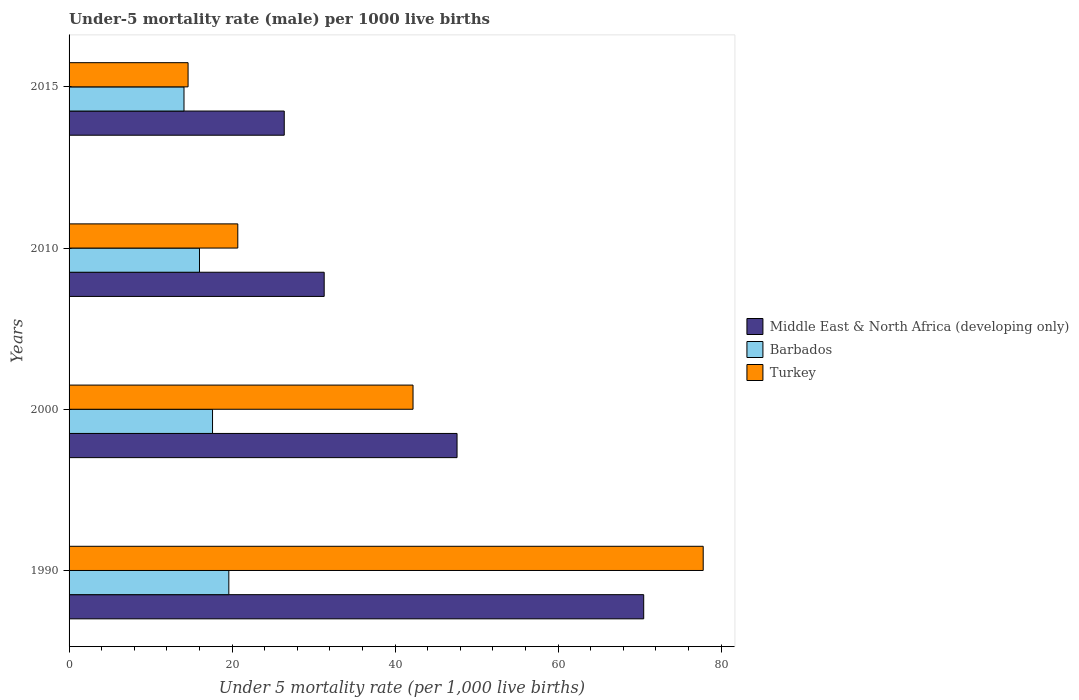How many different coloured bars are there?
Your answer should be very brief. 3. What is the label of the 1st group of bars from the top?
Keep it short and to the point. 2015. In how many cases, is the number of bars for a given year not equal to the number of legend labels?
Offer a very short reply. 0. What is the under-five mortality rate in Turkey in 2015?
Give a very brief answer. 14.6. Across all years, what is the maximum under-five mortality rate in Turkey?
Your answer should be compact. 77.8. In which year was the under-five mortality rate in Turkey maximum?
Provide a short and direct response. 1990. In which year was the under-five mortality rate in Barbados minimum?
Your response must be concise. 2015. What is the total under-five mortality rate in Middle East & North Africa (developing only) in the graph?
Give a very brief answer. 175.8. What is the difference between the under-five mortality rate in Barbados in 1990 and that in 2015?
Make the answer very short. 5.5. What is the difference between the under-five mortality rate in Middle East & North Africa (developing only) in 1990 and the under-five mortality rate in Turkey in 2000?
Your answer should be compact. 28.3. What is the average under-five mortality rate in Middle East & North Africa (developing only) per year?
Keep it short and to the point. 43.95. In the year 2010, what is the difference between the under-five mortality rate in Turkey and under-five mortality rate in Middle East & North Africa (developing only)?
Your response must be concise. -10.6. What is the ratio of the under-five mortality rate in Turkey in 1990 to that in 2010?
Your answer should be compact. 3.76. What is the difference between the highest and the second highest under-five mortality rate in Turkey?
Provide a succinct answer. 35.6. What is the difference between the highest and the lowest under-five mortality rate in Middle East & North Africa (developing only)?
Your answer should be compact. 44.1. Is the sum of the under-five mortality rate in Turkey in 2000 and 2010 greater than the maximum under-five mortality rate in Middle East & North Africa (developing only) across all years?
Provide a short and direct response. No. What does the 2nd bar from the top in 2010 represents?
Offer a terse response. Barbados. What does the 2nd bar from the bottom in 2015 represents?
Provide a succinct answer. Barbados. How many bars are there?
Keep it short and to the point. 12. Are all the bars in the graph horizontal?
Ensure brevity in your answer.  Yes. Are the values on the major ticks of X-axis written in scientific E-notation?
Provide a short and direct response. No. Does the graph contain grids?
Your answer should be compact. No. Where does the legend appear in the graph?
Your answer should be very brief. Center right. How many legend labels are there?
Your answer should be compact. 3. How are the legend labels stacked?
Your answer should be very brief. Vertical. What is the title of the graph?
Make the answer very short. Under-5 mortality rate (male) per 1000 live births. What is the label or title of the X-axis?
Make the answer very short. Under 5 mortality rate (per 1,0 live births). What is the label or title of the Y-axis?
Make the answer very short. Years. What is the Under 5 mortality rate (per 1,000 live births) in Middle East & North Africa (developing only) in 1990?
Give a very brief answer. 70.5. What is the Under 5 mortality rate (per 1,000 live births) in Barbados in 1990?
Provide a short and direct response. 19.6. What is the Under 5 mortality rate (per 1,000 live births) in Turkey in 1990?
Your answer should be compact. 77.8. What is the Under 5 mortality rate (per 1,000 live births) of Middle East & North Africa (developing only) in 2000?
Offer a terse response. 47.6. What is the Under 5 mortality rate (per 1,000 live births) in Barbados in 2000?
Your answer should be compact. 17.6. What is the Under 5 mortality rate (per 1,000 live births) in Turkey in 2000?
Offer a terse response. 42.2. What is the Under 5 mortality rate (per 1,000 live births) of Middle East & North Africa (developing only) in 2010?
Your answer should be very brief. 31.3. What is the Under 5 mortality rate (per 1,000 live births) in Barbados in 2010?
Give a very brief answer. 16. What is the Under 5 mortality rate (per 1,000 live births) of Turkey in 2010?
Offer a very short reply. 20.7. What is the Under 5 mortality rate (per 1,000 live births) of Middle East & North Africa (developing only) in 2015?
Make the answer very short. 26.4. Across all years, what is the maximum Under 5 mortality rate (per 1,000 live births) in Middle East & North Africa (developing only)?
Your answer should be compact. 70.5. Across all years, what is the maximum Under 5 mortality rate (per 1,000 live births) of Barbados?
Provide a short and direct response. 19.6. Across all years, what is the maximum Under 5 mortality rate (per 1,000 live births) of Turkey?
Provide a succinct answer. 77.8. Across all years, what is the minimum Under 5 mortality rate (per 1,000 live births) of Middle East & North Africa (developing only)?
Ensure brevity in your answer.  26.4. What is the total Under 5 mortality rate (per 1,000 live births) of Middle East & North Africa (developing only) in the graph?
Keep it short and to the point. 175.8. What is the total Under 5 mortality rate (per 1,000 live births) of Barbados in the graph?
Provide a succinct answer. 67.3. What is the total Under 5 mortality rate (per 1,000 live births) of Turkey in the graph?
Offer a very short reply. 155.3. What is the difference between the Under 5 mortality rate (per 1,000 live births) of Middle East & North Africa (developing only) in 1990 and that in 2000?
Ensure brevity in your answer.  22.9. What is the difference between the Under 5 mortality rate (per 1,000 live births) of Turkey in 1990 and that in 2000?
Offer a terse response. 35.6. What is the difference between the Under 5 mortality rate (per 1,000 live births) in Middle East & North Africa (developing only) in 1990 and that in 2010?
Your response must be concise. 39.2. What is the difference between the Under 5 mortality rate (per 1,000 live births) of Barbados in 1990 and that in 2010?
Give a very brief answer. 3.6. What is the difference between the Under 5 mortality rate (per 1,000 live births) in Turkey in 1990 and that in 2010?
Keep it short and to the point. 57.1. What is the difference between the Under 5 mortality rate (per 1,000 live births) of Middle East & North Africa (developing only) in 1990 and that in 2015?
Your answer should be very brief. 44.1. What is the difference between the Under 5 mortality rate (per 1,000 live births) in Turkey in 1990 and that in 2015?
Your answer should be compact. 63.2. What is the difference between the Under 5 mortality rate (per 1,000 live births) in Barbados in 2000 and that in 2010?
Your answer should be compact. 1.6. What is the difference between the Under 5 mortality rate (per 1,000 live births) of Middle East & North Africa (developing only) in 2000 and that in 2015?
Offer a terse response. 21.2. What is the difference between the Under 5 mortality rate (per 1,000 live births) in Turkey in 2000 and that in 2015?
Offer a very short reply. 27.6. What is the difference between the Under 5 mortality rate (per 1,000 live births) in Middle East & North Africa (developing only) in 2010 and that in 2015?
Offer a terse response. 4.9. What is the difference between the Under 5 mortality rate (per 1,000 live births) of Barbados in 2010 and that in 2015?
Provide a short and direct response. 1.9. What is the difference between the Under 5 mortality rate (per 1,000 live births) of Turkey in 2010 and that in 2015?
Offer a terse response. 6.1. What is the difference between the Under 5 mortality rate (per 1,000 live births) in Middle East & North Africa (developing only) in 1990 and the Under 5 mortality rate (per 1,000 live births) in Barbados in 2000?
Your answer should be compact. 52.9. What is the difference between the Under 5 mortality rate (per 1,000 live births) of Middle East & North Africa (developing only) in 1990 and the Under 5 mortality rate (per 1,000 live births) of Turkey in 2000?
Your answer should be very brief. 28.3. What is the difference between the Under 5 mortality rate (per 1,000 live births) of Barbados in 1990 and the Under 5 mortality rate (per 1,000 live births) of Turkey in 2000?
Offer a terse response. -22.6. What is the difference between the Under 5 mortality rate (per 1,000 live births) of Middle East & North Africa (developing only) in 1990 and the Under 5 mortality rate (per 1,000 live births) of Barbados in 2010?
Your answer should be compact. 54.5. What is the difference between the Under 5 mortality rate (per 1,000 live births) in Middle East & North Africa (developing only) in 1990 and the Under 5 mortality rate (per 1,000 live births) in Turkey in 2010?
Your response must be concise. 49.8. What is the difference between the Under 5 mortality rate (per 1,000 live births) of Barbados in 1990 and the Under 5 mortality rate (per 1,000 live births) of Turkey in 2010?
Your response must be concise. -1.1. What is the difference between the Under 5 mortality rate (per 1,000 live births) in Middle East & North Africa (developing only) in 1990 and the Under 5 mortality rate (per 1,000 live births) in Barbados in 2015?
Your response must be concise. 56.4. What is the difference between the Under 5 mortality rate (per 1,000 live births) of Middle East & North Africa (developing only) in 1990 and the Under 5 mortality rate (per 1,000 live births) of Turkey in 2015?
Provide a succinct answer. 55.9. What is the difference between the Under 5 mortality rate (per 1,000 live births) of Middle East & North Africa (developing only) in 2000 and the Under 5 mortality rate (per 1,000 live births) of Barbados in 2010?
Offer a very short reply. 31.6. What is the difference between the Under 5 mortality rate (per 1,000 live births) of Middle East & North Africa (developing only) in 2000 and the Under 5 mortality rate (per 1,000 live births) of Turkey in 2010?
Offer a terse response. 26.9. What is the difference between the Under 5 mortality rate (per 1,000 live births) in Middle East & North Africa (developing only) in 2000 and the Under 5 mortality rate (per 1,000 live births) in Barbados in 2015?
Make the answer very short. 33.5. What is the difference between the Under 5 mortality rate (per 1,000 live births) in Middle East & North Africa (developing only) in 2000 and the Under 5 mortality rate (per 1,000 live births) in Turkey in 2015?
Your response must be concise. 33. What is the difference between the Under 5 mortality rate (per 1,000 live births) of Middle East & North Africa (developing only) in 2010 and the Under 5 mortality rate (per 1,000 live births) of Barbados in 2015?
Make the answer very short. 17.2. What is the difference between the Under 5 mortality rate (per 1,000 live births) in Middle East & North Africa (developing only) in 2010 and the Under 5 mortality rate (per 1,000 live births) in Turkey in 2015?
Provide a succinct answer. 16.7. What is the difference between the Under 5 mortality rate (per 1,000 live births) of Barbados in 2010 and the Under 5 mortality rate (per 1,000 live births) of Turkey in 2015?
Give a very brief answer. 1.4. What is the average Under 5 mortality rate (per 1,000 live births) of Middle East & North Africa (developing only) per year?
Offer a very short reply. 43.95. What is the average Under 5 mortality rate (per 1,000 live births) in Barbados per year?
Keep it short and to the point. 16.82. What is the average Under 5 mortality rate (per 1,000 live births) in Turkey per year?
Give a very brief answer. 38.83. In the year 1990, what is the difference between the Under 5 mortality rate (per 1,000 live births) in Middle East & North Africa (developing only) and Under 5 mortality rate (per 1,000 live births) in Barbados?
Offer a terse response. 50.9. In the year 1990, what is the difference between the Under 5 mortality rate (per 1,000 live births) in Middle East & North Africa (developing only) and Under 5 mortality rate (per 1,000 live births) in Turkey?
Your answer should be compact. -7.3. In the year 1990, what is the difference between the Under 5 mortality rate (per 1,000 live births) in Barbados and Under 5 mortality rate (per 1,000 live births) in Turkey?
Your answer should be very brief. -58.2. In the year 2000, what is the difference between the Under 5 mortality rate (per 1,000 live births) of Middle East & North Africa (developing only) and Under 5 mortality rate (per 1,000 live births) of Barbados?
Give a very brief answer. 30. In the year 2000, what is the difference between the Under 5 mortality rate (per 1,000 live births) of Middle East & North Africa (developing only) and Under 5 mortality rate (per 1,000 live births) of Turkey?
Offer a terse response. 5.4. In the year 2000, what is the difference between the Under 5 mortality rate (per 1,000 live births) of Barbados and Under 5 mortality rate (per 1,000 live births) of Turkey?
Your answer should be very brief. -24.6. In the year 2010, what is the difference between the Under 5 mortality rate (per 1,000 live births) of Middle East & North Africa (developing only) and Under 5 mortality rate (per 1,000 live births) of Barbados?
Keep it short and to the point. 15.3. In the year 2010, what is the difference between the Under 5 mortality rate (per 1,000 live births) of Middle East & North Africa (developing only) and Under 5 mortality rate (per 1,000 live births) of Turkey?
Provide a succinct answer. 10.6. In the year 2010, what is the difference between the Under 5 mortality rate (per 1,000 live births) in Barbados and Under 5 mortality rate (per 1,000 live births) in Turkey?
Offer a terse response. -4.7. In the year 2015, what is the difference between the Under 5 mortality rate (per 1,000 live births) of Middle East & North Africa (developing only) and Under 5 mortality rate (per 1,000 live births) of Barbados?
Provide a short and direct response. 12.3. In the year 2015, what is the difference between the Under 5 mortality rate (per 1,000 live births) of Barbados and Under 5 mortality rate (per 1,000 live births) of Turkey?
Give a very brief answer. -0.5. What is the ratio of the Under 5 mortality rate (per 1,000 live births) in Middle East & North Africa (developing only) in 1990 to that in 2000?
Ensure brevity in your answer.  1.48. What is the ratio of the Under 5 mortality rate (per 1,000 live births) in Barbados in 1990 to that in 2000?
Offer a very short reply. 1.11. What is the ratio of the Under 5 mortality rate (per 1,000 live births) of Turkey in 1990 to that in 2000?
Provide a short and direct response. 1.84. What is the ratio of the Under 5 mortality rate (per 1,000 live births) of Middle East & North Africa (developing only) in 1990 to that in 2010?
Offer a terse response. 2.25. What is the ratio of the Under 5 mortality rate (per 1,000 live births) in Barbados in 1990 to that in 2010?
Offer a terse response. 1.23. What is the ratio of the Under 5 mortality rate (per 1,000 live births) in Turkey in 1990 to that in 2010?
Provide a succinct answer. 3.76. What is the ratio of the Under 5 mortality rate (per 1,000 live births) of Middle East & North Africa (developing only) in 1990 to that in 2015?
Offer a very short reply. 2.67. What is the ratio of the Under 5 mortality rate (per 1,000 live births) in Barbados in 1990 to that in 2015?
Ensure brevity in your answer.  1.39. What is the ratio of the Under 5 mortality rate (per 1,000 live births) of Turkey in 1990 to that in 2015?
Your answer should be very brief. 5.33. What is the ratio of the Under 5 mortality rate (per 1,000 live births) of Middle East & North Africa (developing only) in 2000 to that in 2010?
Provide a short and direct response. 1.52. What is the ratio of the Under 5 mortality rate (per 1,000 live births) of Barbados in 2000 to that in 2010?
Your response must be concise. 1.1. What is the ratio of the Under 5 mortality rate (per 1,000 live births) in Turkey in 2000 to that in 2010?
Give a very brief answer. 2.04. What is the ratio of the Under 5 mortality rate (per 1,000 live births) in Middle East & North Africa (developing only) in 2000 to that in 2015?
Keep it short and to the point. 1.8. What is the ratio of the Under 5 mortality rate (per 1,000 live births) in Barbados in 2000 to that in 2015?
Provide a succinct answer. 1.25. What is the ratio of the Under 5 mortality rate (per 1,000 live births) of Turkey in 2000 to that in 2015?
Provide a short and direct response. 2.89. What is the ratio of the Under 5 mortality rate (per 1,000 live births) in Middle East & North Africa (developing only) in 2010 to that in 2015?
Ensure brevity in your answer.  1.19. What is the ratio of the Under 5 mortality rate (per 1,000 live births) of Barbados in 2010 to that in 2015?
Provide a succinct answer. 1.13. What is the ratio of the Under 5 mortality rate (per 1,000 live births) of Turkey in 2010 to that in 2015?
Provide a succinct answer. 1.42. What is the difference between the highest and the second highest Under 5 mortality rate (per 1,000 live births) of Middle East & North Africa (developing only)?
Your response must be concise. 22.9. What is the difference between the highest and the second highest Under 5 mortality rate (per 1,000 live births) in Barbados?
Provide a succinct answer. 2. What is the difference between the highest and the second highest Under 5 mortality rate (per 1,000 live births) of Turkey?
Offer a terse response. 35.6. What is the difference between the highest and the lowest Under 5 mortality rate (per 1,000 live births) in Middle East & North Africa (developing only)?
Give a very brief answer. 44.1. What is the difference between the highest and the lowest Under 5 mortality rate (per 1,000 live births) of Barbados?
Make the answer very short. 5.5. What is the difference between the highest and the lowest Under 5 mortality rate (per 1,000 live births) in Turkey?
Ensure brevity in your answer.  63.2. 